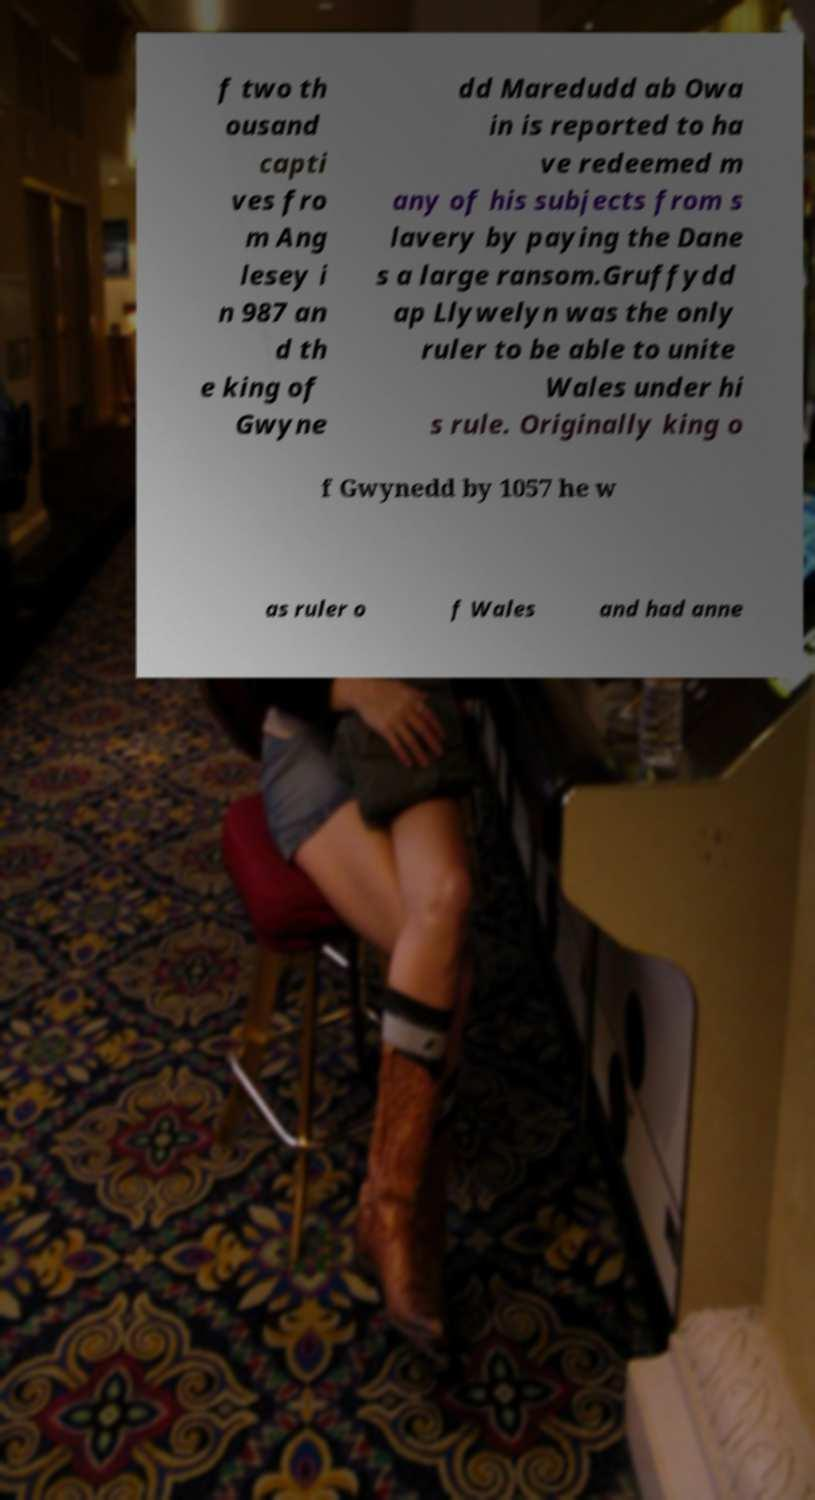Can you accurately transcribe the text from the provided image for me? f two th ousand capti ves fro m Ang lesey i n 987 an d th e king of Gwyne dd Maredudd ab Owa in is reported to ha ve redeemed m any of his subjects from s lavery by paying the Dane s a large ransom.Gruffydd ap Llywelyn was the only ruler to be able to unite Wales under hi s rule. Originally king o f Gwynedd by 1057 he w as ruler o f Wales and had anne 